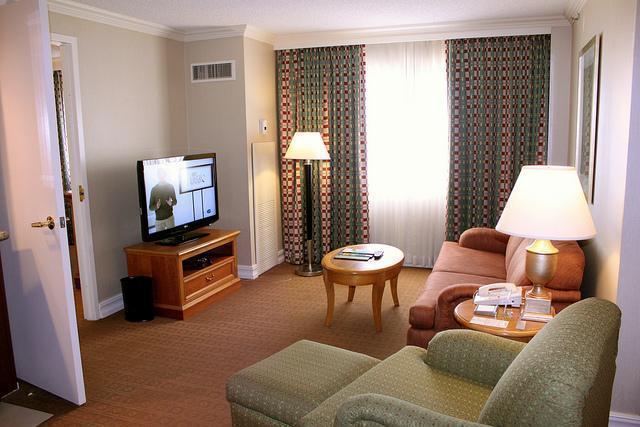What is the appliance in this room used for?
Choose the right answer from the provided options to respond to the question.
Options: Cooling, watching, cooking, washing. Watching. 